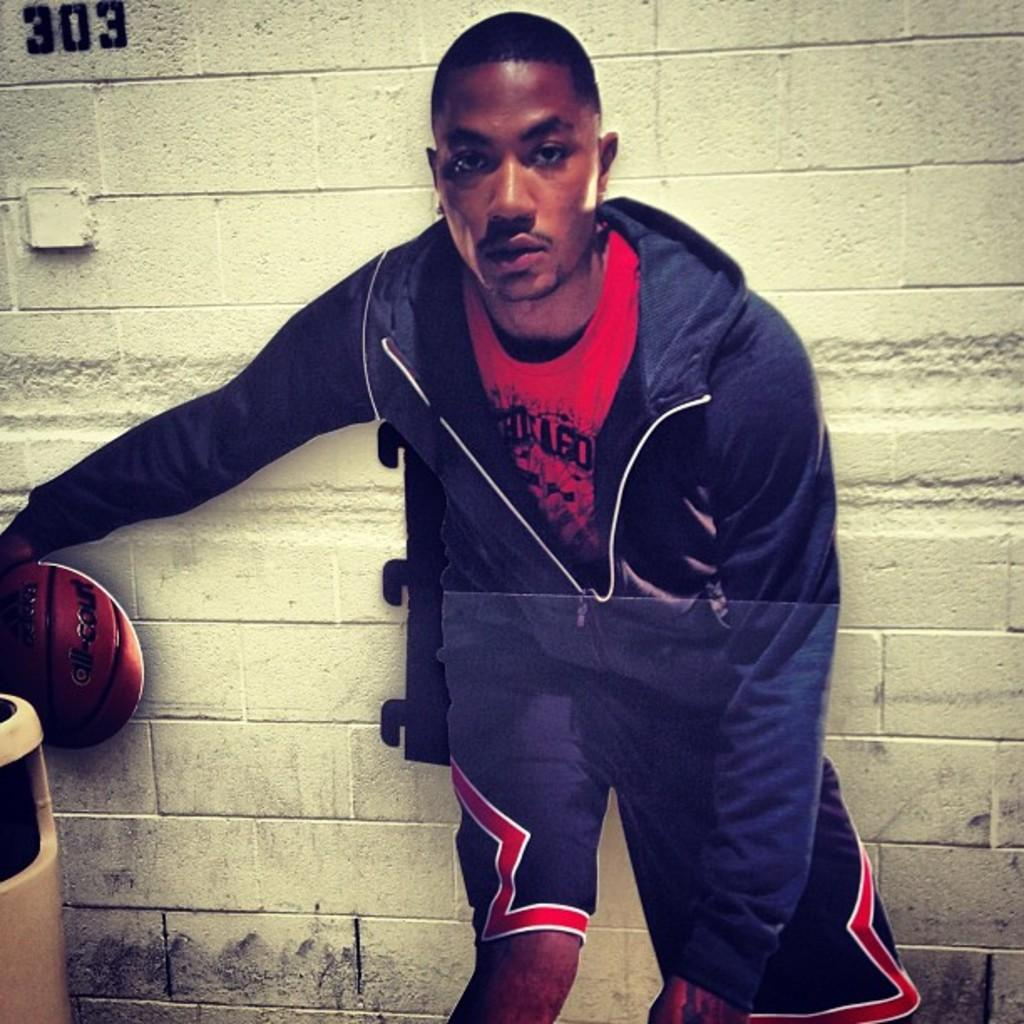<image>
Relay a brief, clear account of the picture shown. A man is drippling an adidas all-court basketball in front of a brick wall with the number 303 on it. 